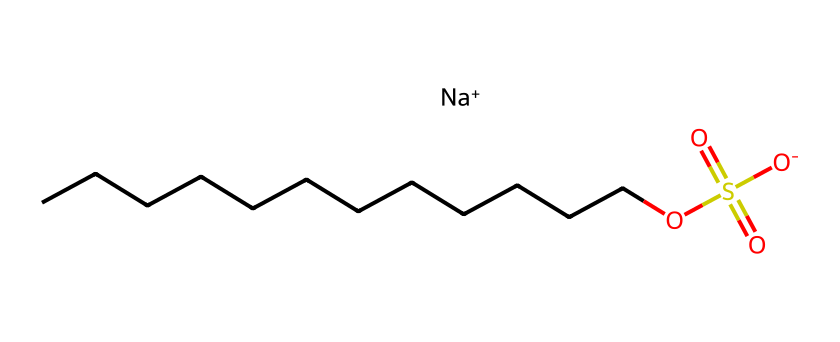How many carbon atoms are in sodium lauryl sulfate? The chemical structure represented by the SMILES indicates a long carbon chain, specifically "CCCCCCCCCCCC", which indicates there are 12 carbon atoms in total.
Answer: 12 What functional group is present in sodium lauryl sulfate? The SMILES representation contains a "OS(=O)(=O)" segment, indicating the presence of a sulfonate functional group which is characteristic of sulfonates and sulfates.
Answer: sulfonate How many sulfur atoms are in sodium lauryl sulfate? By examining the structure, we see there is one occurrence of "S" in the chemical formula, indicating that there is 1 sulfur atom present in the molecule.
Answer: 1 What type of surfactant is sodium lauryl sulfate? Sodium lauryl sulfate is identified as an anionic surfactant because it contains a negatively charged sulfonate group, as indicated in the SMILES notation.
Answer: anionic What is the charge on the sodium ion in sodium lauryl sulfate? In the SMILES representation, the sodium ion is shown as "[Na+]", indicating that it carries a positive charge of +1.
Answer: +1 How many oxygen atoms are present in sodium lauryl sulfate? In the SMILES representation, the segment "OS(=O)(=O)" shows that there are three oxygen atoms bonded to the sulfur atom and an additional oxygen in the sulfonate group, resulting in a total of 4 oxygen atoms.
Answer: 4 